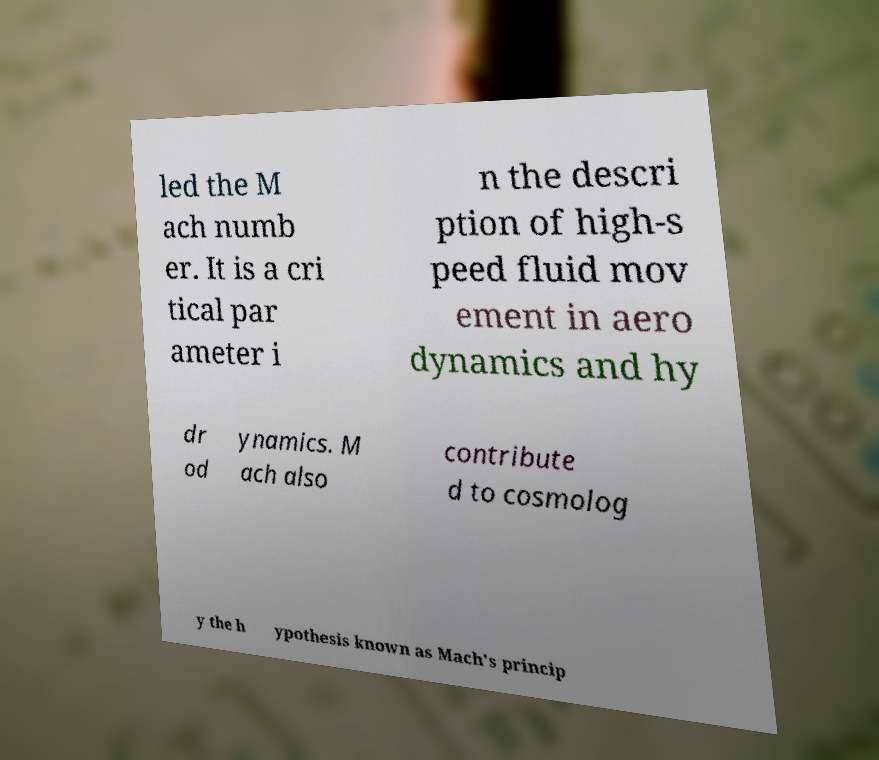What messages or text are displayed in this image? I need them in a readable, typed format. led the M ach numb er. It is a cri tical par ameter i n the descri ption of high-s peed fluid mov ement in aero dynamics and hy dr od ynamics. M ach also contribute d to cosmolog y the h ypothesis known as Mach's princip 